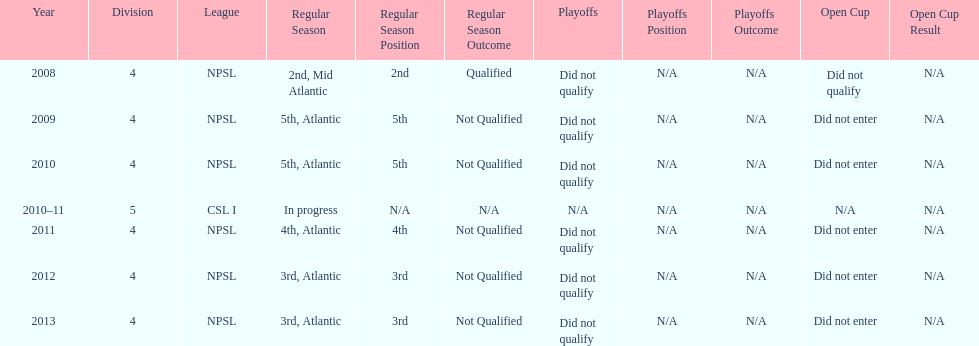Which year was more successful, 2010 or 2013? 2013. 